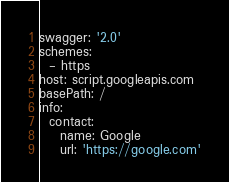Convert code to text. <code><loc_0><loc_0><loc_500><loc_500><_YAML_>swagger: '2.0'
schemes:
  - https
host: script.googleapis.com
basePath: /
info:
  contact:
    name: Google
    url: 'https://google.com'</code> 